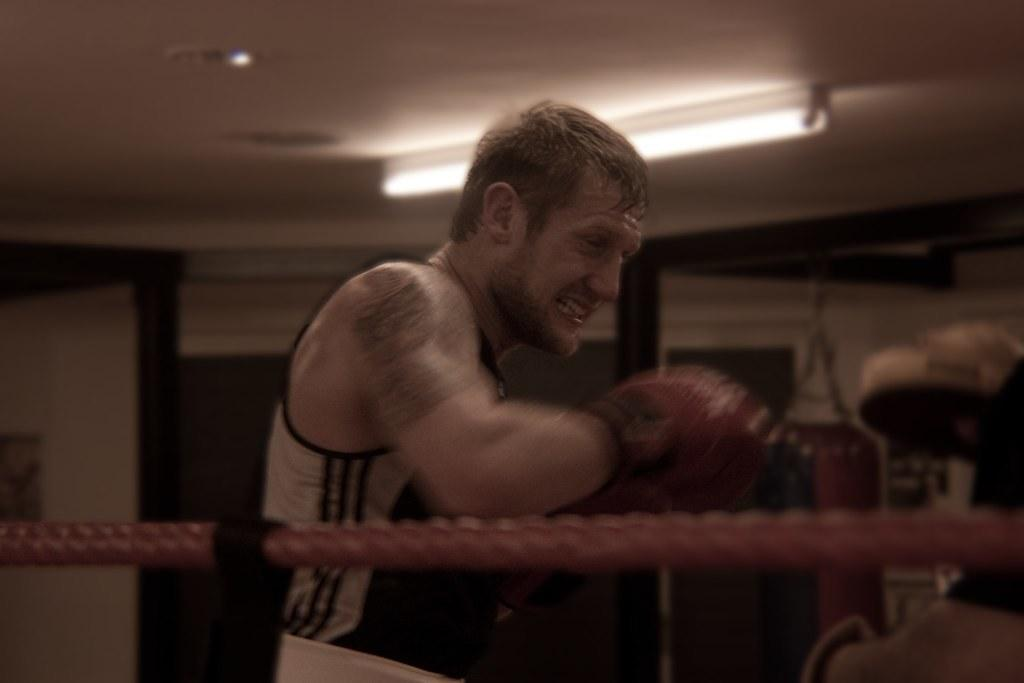Who is the main subject in the image? There is a man in the middle of the image. What is the man doing in the image? The man is wrestling. What object can be seen at the bottom of the image? There is a rope at the bottom of the image. What can be seen at the top of the image? There is a light at the top of the image. How does the kite affect the man's wrestling in the image? There is no kite present in the image, so it cannot affect the man's wrestling. 